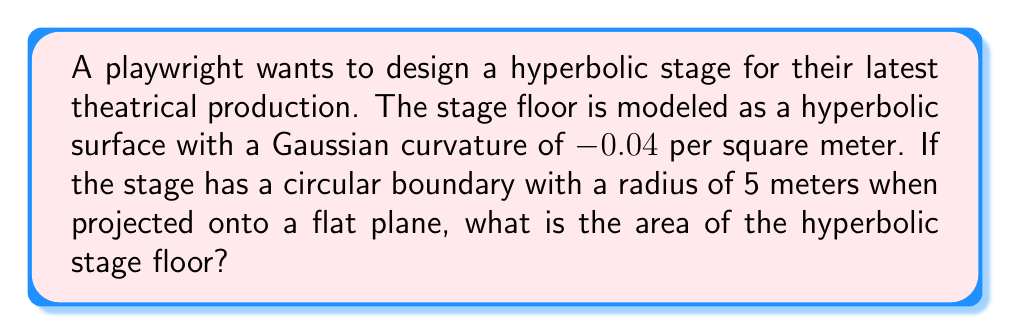Show me your answer to this math problem. To solve this problem, we'll use the Gauss-Bonnet theorem for hyperbolic geometry. Let's approach this step-by-step:

1) The Gauss-Bonnet theorem for a hyperbolic disk states:

   $$A = \frac{2\pi}{|K|} (\cosh(r\sqrt{|K|}) - 1)$$

   Where:
   $A$ is the area of the hyperbolic disk
   $K$ is the Gaussian curvature
   $r$ is the radius of the disk when projected onto a flat plane

2) We're given:
   $K = -0.04$ per square meter
   $r = 5$ meters

3) Let's substitute these values into the formula:

   $$A = \frac{2\pi}{|-0.04|} (\cosh(5\sqrt{|-0.04|}) - 1)$$

4) Simplify:
   $$A = 50\pi (\cosh(1) - 1)$$

5) Calculate:
   $\cosh(1) \approx 1.5430806348152437$

6) Substitute and calculate the final result:
   $$A = 50\pi (1.5430806348152437 - 1) \approx 85.4$$

Therefore, the area of the hyperbolic stage floor is approximately 85.4 square meters.
Answer: 85.4 m² 